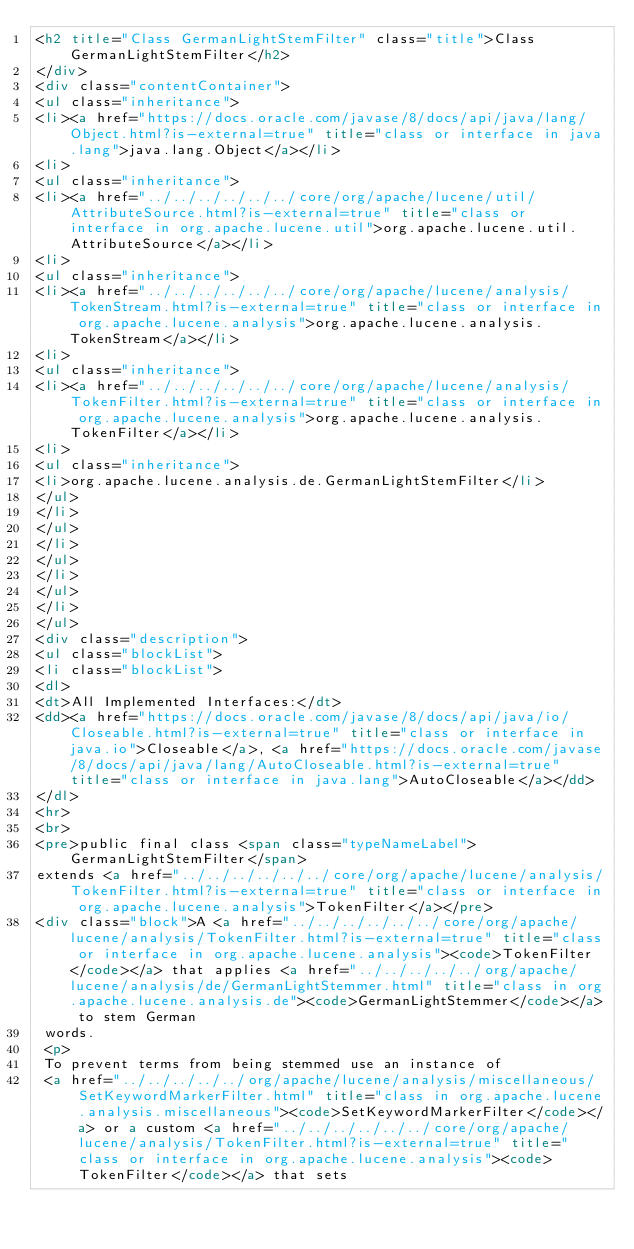Convert code to text. <code><loc_0><loc_0><loc_500><loc_500><_HTML_><h2 title="Class GermanLightStemFilter" class="title">Class GermanLightStemFilter</h2>
</div>
<div class="contentContainer">
<ul class="inheritance">
<li><a href="https://docs.oracle.com/javase/8/docs/api/java/lang/Object.html?is-external=true" title="class or interface in java.lang">java.lang.Object</a></li>
<li>
<ul class="inheritance">
<li><a href="../../../../../../core/org/apache/lucene/util/AttributeSource.html?is-external=true" title="class or interface in org.apache.lucene.util">org.apache.lucene.util.AttributeSource</a></li>
<li>
<ul class="inheritance">
<li><a href="../../../../../../core/org/apache/lucene/analysis/TokenStream.html?is-external=true" title="class or interface in org.apache.lucene.analysis">org.apache.lucene.analysis.TokenStream</a></li>
<li>
<ul class="inheritance">
<li><a href="../../../../../../core/org/apache/lucene/analysis/TokenFilter.html?is-external=true" title="class or interface in org.apache.lucene.analysis">org.apache.lucene.analysis.TokenFilter</a></li>
<li>
<ul class="inheritance">
<li>org.apache.lucene.analysis.de.GermanLightStemFilter</li>
</ul>
</li>
</ul>
</li>
</ul>
</li>
</ul>
</li>
</ul>
<div class="description">
<ul class="blockList">
<li class="blockList">
<dl>
<dt>All Implemented Interfaces:</dt>
<dd><a href="https://docs.oracle.com/javase/8/docs/api/java/io/Closeable.html?is-external=true" title="class or interface in java.io">Closeable</a>, <a href="https://docs.oracle.com/javase/8/docs/api/java/lang/AutoCloseable.html?is-external=true" title="class or interface in java.lang">AutoCloseable</a></dd>
</dl>
<hr>
<br>
<pre>public final class <span class="typeNameLabel">GermanLightStemFilter</span>
extends <a href="../../../../../../core/org/apache/lucene/analysis/TokenFilter.html?is-external=true" title="class or interface in org.apache.lucene.analysis">TokenFilter</a></pre>
<div class="block">A <a href="../../../../../../core/org/apache/lucene/analysis/TokenFilter.html?is-external=true" title="class or interface in org.apache.lucene.analysis"><code>TokenFilter</code></a> that applies <a href="../../../../../org/apache/lucene/analysis/de/GermanLightStemmer.html" title="class in org.apache.lucene.analysis.de"><code>GermanLightStemmer</code></a> to stem German
 words.
 <p>
 To prevent terms from being stemmed use an instance of
 <a href="../../../../../org/apache/lucene/analysis/miscellaneous/SetKeywordMarkerFilter.html" title="class in org.apache.lucene.analysis.miscellaneous"><code>SetKeywordMarkerFilter</code></a> or a custom <a href="../../../../../../core/org/apache/lucene/analysis/TokenFilter.html?is-external=true" title="class or interface in org.apache.lucene.analysis"><code>TokenFilter</code></a> that sets</code> 